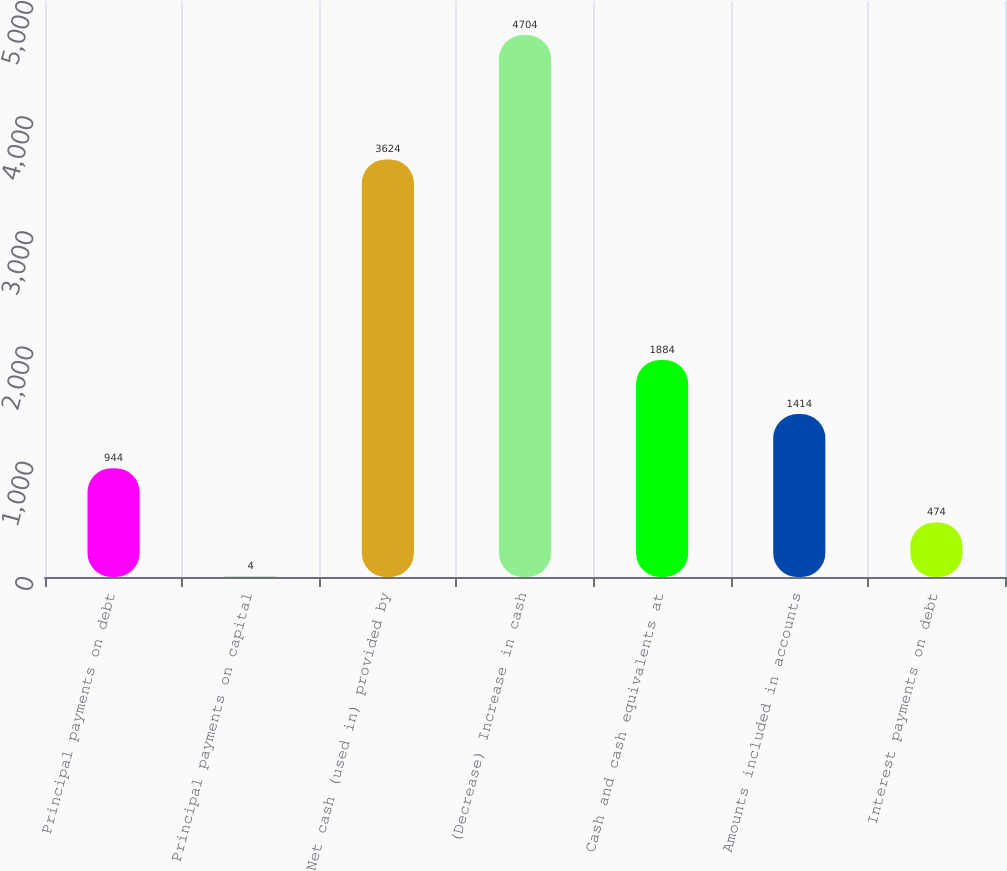<chart> <loc_0><loc_0><loc_500><loc_500><bar_chart><fcel>Principal payments on debt<fcel>Principal payments on capital<fcel>Net cash (used in) provided by<fcel>(Decrease) Increase in cash<fcel>Cash and cash equivalents at<fcel>Amounts included in accounts<fcel>Interest payments on debt<nl><fcel>944<fcel>4<fcel>3624<fcel>4704<fcel>1884<fcel>1414<fcel>474<nl></chart> 